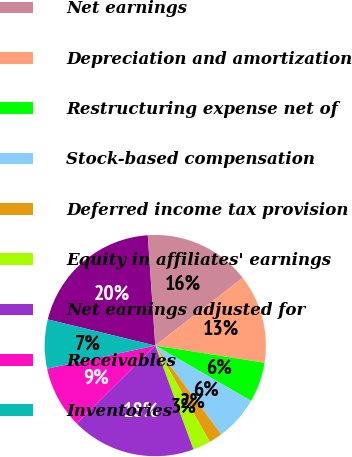Convert chart to OTSL. <chart><loc_0><loc_0><loc_500><loc_500><pie_chart><fcel>(in millions of dollars)<fcel>Net earnings<fcel>Depreciation and amortization<fcel>Restructuring expense net of<fcel>Stock-based compensation<fcel>Deferred income tax provision<fcel>Equity in affiliates' earnings<fcel>Net earnings adjusted for<fcel>Receivables<fcel>Inventories<nl><fcel>20.12%<fcel>15.58%<fcel>12.98%<fcel>5.85%<fcel>6.5%<fcel>1.96%<fcel>2.61%<fcel>18.17%<fcel>9.09%<fcel>7.15%<nl></chart> 